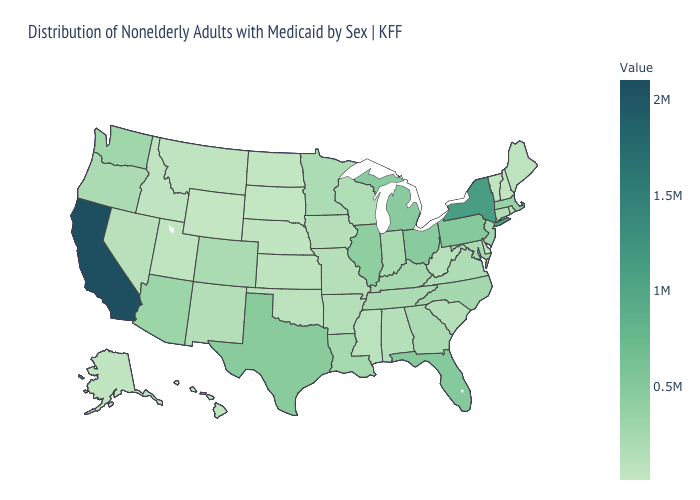Which states have the lowest value in the Northeast?
Keep it brief. New Hampshire. Which states have the lowest value in the USA?
Quick response, please. Wyoming. Which states have the highest value in the USA?
Keep it brief. California. Which states have the highest value in the USA?
Concise answer only. California. Among the states that border Maryland , does Delaware have the lowest value?
Be succinct. Yes. Does Colorado have a higher value than Texas?
Answer briefly. No. 